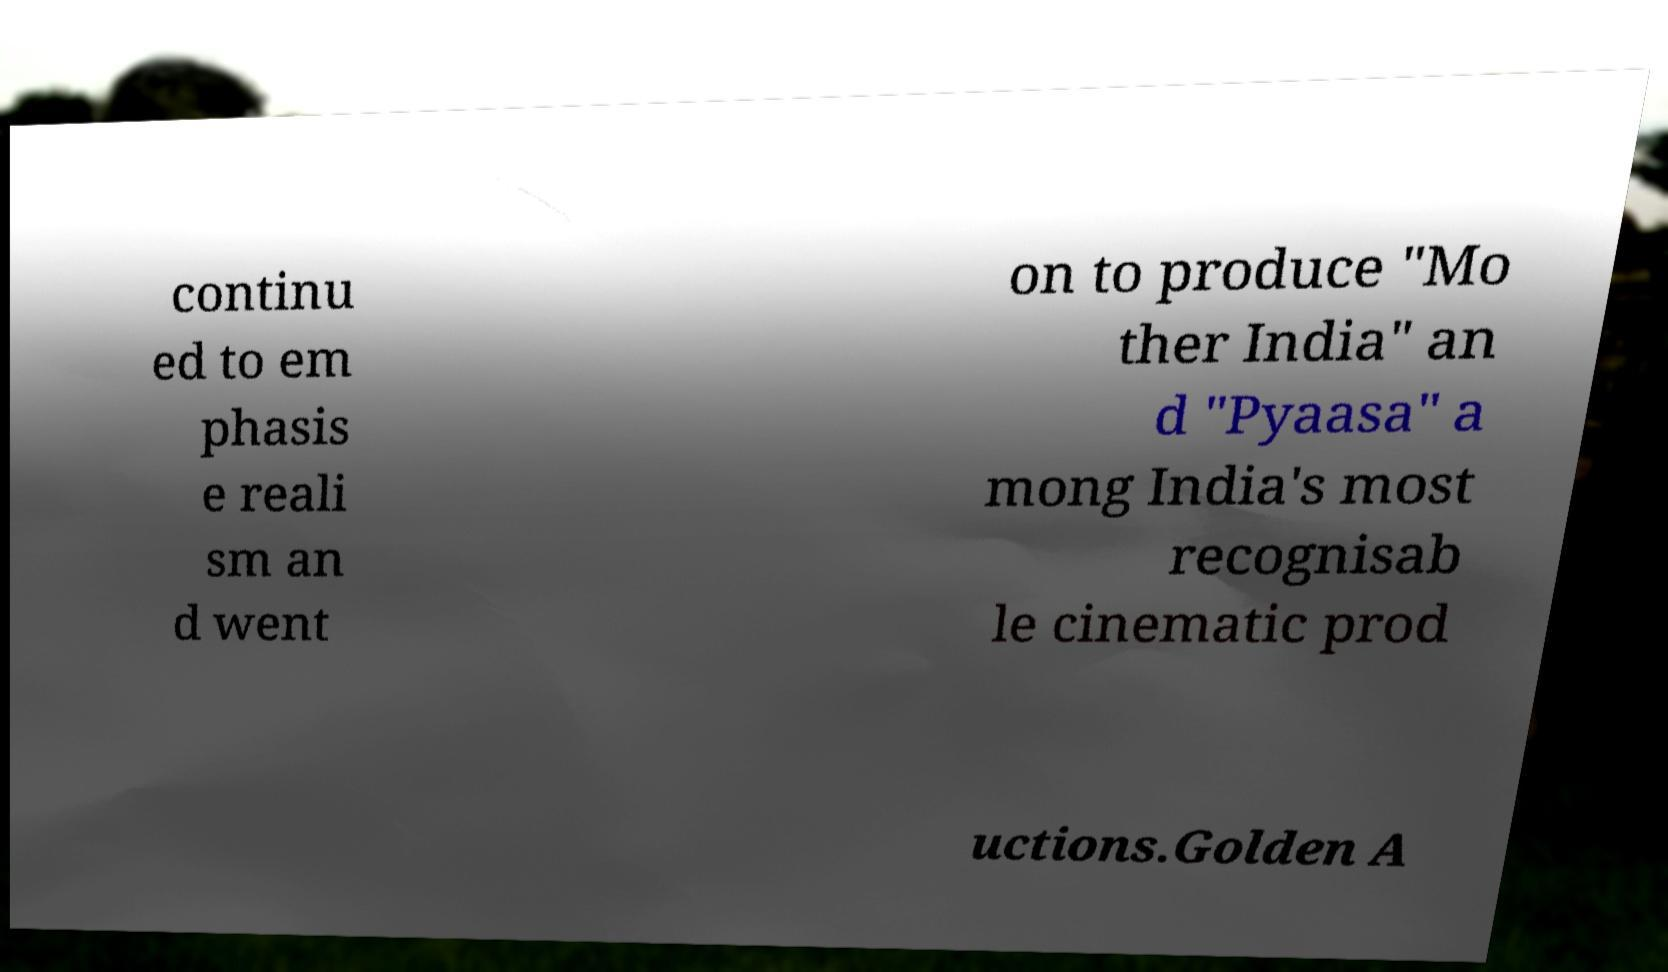Could you extract and type out the text from this image? continu ed to em phasis e reali sm an d went on to produce "Mo ther India" an d "Pyaasa" a mong India's most recognisab le cinematic prod uctions.Golden A 